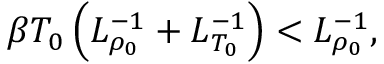Convert formula to latex. <formula><loc_0><loc_0><loc_500><loc_500>\beta T _ { 0 } \left ( L _ { \rho _ { 0 } } ^ { - 1 } + L _ { T _ { 0 } } ^ { - 1 } \right ) < L _ { \rho _ { 0 } } ^ { - 1 } ,</formula> 